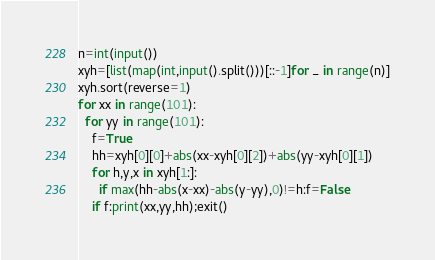Convert code to text. <code><loc_0><loc_0><loc_500><loc_500><_Python_>n=int(input())
xyh=[list(map(int,input().split()))[::-1]for _ in range(n)]
xyh.sort(reverse=1)
for xx in range(101):
  for yy in range(101):
    f=True
    hh=xyh[0][0]+abs(xx-xyh[0][2])+abs(yy-xyh[0][1])
    for h,y,x in xyh[1:]:
      if max(hh-abs(x-xx)-abs(y-yy),0)!=h:f=False
    if f:print(xx,yy,hh);exit()</code> 